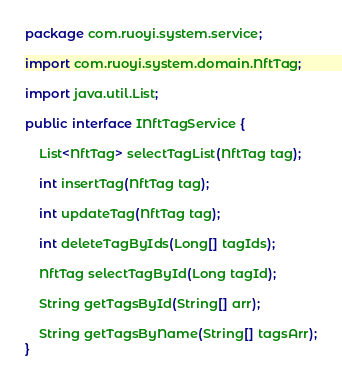<code> <loc_0><loc_0><loc_500><loc_500><_Java_>package com.ruoyi.system.service;

import com.ruoyi.system.domain.NftTag;

import java.util.List;

public interface INftTagService {

    List<NftTag> selectTagList(NftTag tag);

    int insertTag(NftTag tag);

    int updateTag(NftTag tag);

    int deleteTagByIds(Long[] tagIds);

    NftTag selectTagById(Long tagId);

    String getTagsById(String[] arr);

    String getTagsByName(String[] tagsArr);
}
</code> 